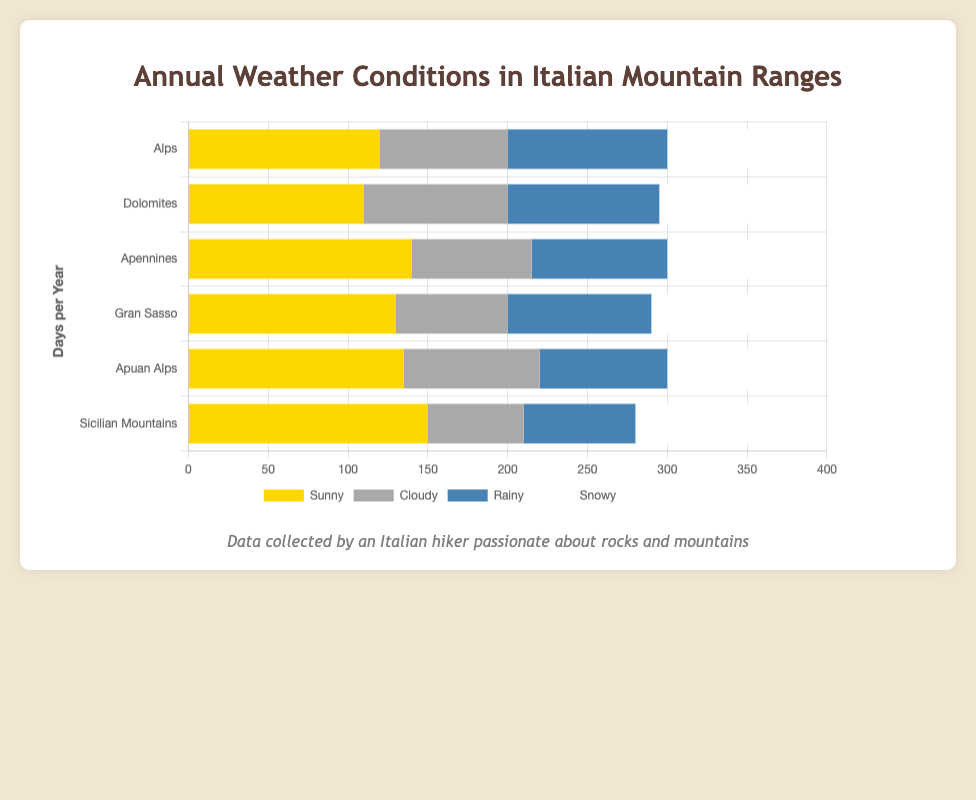What range has the highest number of sunny days? By visually inspecting the bar lengths for the sunny days across all mountain ranges, we can see that the Sicilian Mountains have the longest bar representing sunny days.
Answer: Sicilian Mountains Which mountain range experiences the most snowfall annually? By comparing the lengths of the snowy bars, we can see that the Sicilian Mountains have the longest snowy bar.
Answer: Sicilian Mountains How many more sunny days do the Apennines have compared to the Dolomites? The Apennines have 140 sunny days whereas the Dolomites have 110 sunny days. By subtracting the number of sunny days in the Dolomites from the sunny days in the Apennines, we get 140 - 110.
Answer: 30 Which mountain range has the fewest rainy days? By comparing the lengths of the rainy bars, the Sicilian Mountains have the shortest rainy bar.
Answer: Sicilian Mountains What is the total number of snowy days in all mountain ranges combined? To get the total number of snowy days, we sum the snowy days for all ranges: 65 (Alps) + 70 (Dolomites) + 65 (Apennines) + 75 (Gran Sasso) + 65 (Apuan Alps) + 85 (Sicilian Mountains). The total is 425 snowy days.
Answer: 425 How does the number of cloudy days in Gran Sasso compare to the Sicilian Mountains? Gran Sasso has 70 cloudy days while the Sicilian Mountains have 60 cloudy days. Gran Sasso has 10 more cloudy days than the Sicilian Mountains.
Answer: Gran Sasso has 10 more days Which mountain range has the greatest variability in weather conditions? The Sicilian Mountains show notable differences in the length of bars for each weather condition compared to the other ranges, indicating the most variability.
Answer: Sicilian Mountains What is the average number of rainy days across all the mountain ranges? To calculate the average, we sum the number of rainy days for all ranges and divide by the number of ranges: (100 + 95 + 85 + 90 + 80 + 70) / 6 = 86.67.
Answer: 86.67 How many total days do the Alps experience non-sunny weather annually? By summing the days of cloudy, rainy, and snowy weather for the Alps, we get 80 (Cloudy) + 100 (Rainy) + 65 (Snowy) = 245.
Answer: 245 Which mountain range has the longest duration of cloudy weather? By comparing the bars representing cloudy days, the Dolomites have the longest bar for cloudy weather with 90 days.
Answer: Dolomites 